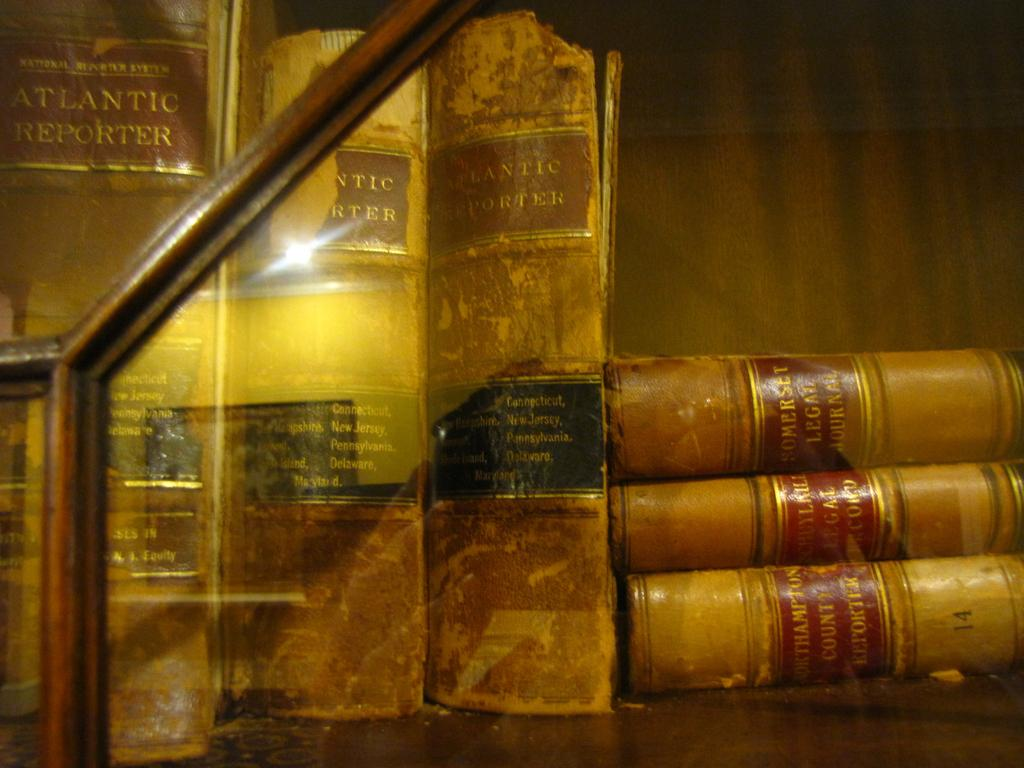Provide a one-sentence caption for the provided image. old books on a shelf, three Atlantic Reporter standing and three Southampton County Reporter laying flat. 